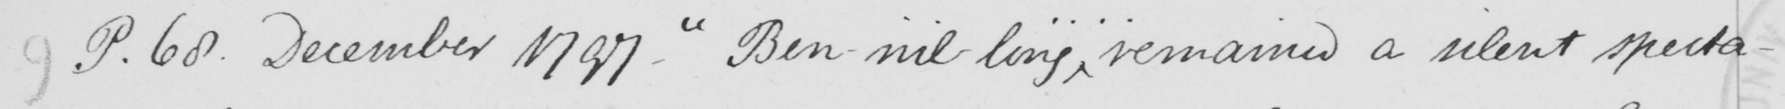What text is written in this handwritten line? 9 P.68 . December 1797 .  " Ben-nil-ling ... . remains a silent specta- 